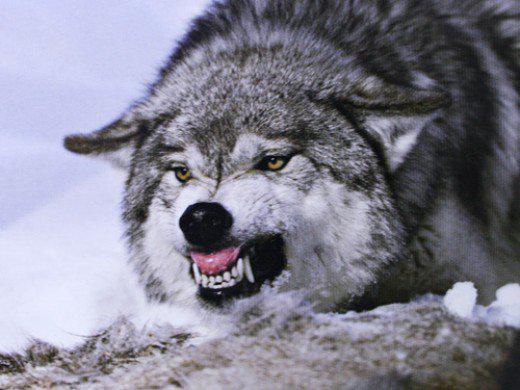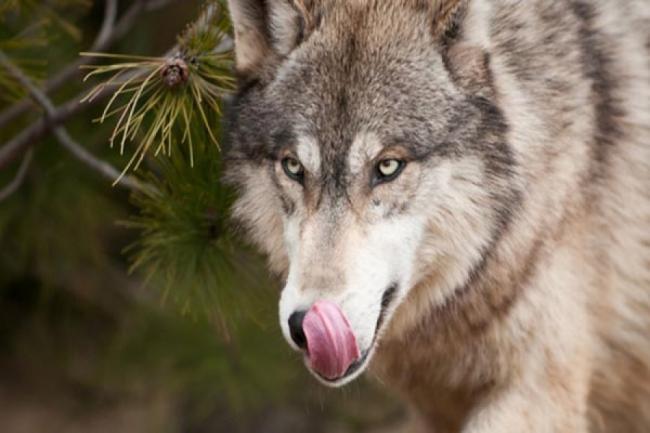The first image is the image on the left, the second image is the image on the right. Evaluate the accuracy of this statement regarding the images: "One image features one wolf with snow on its nose, and the other image contains a single wolf, which has its mouth open showing its teeth and stands with its body forward and its head turned rightward.". Is it true? Answer yes or no. No. The first image is the image on the left, the second image is the image on the right. Analyze the images presented: Is the assertion "The wolf in the image on the right has its mouth closed." valid? Answer yes or no. No. 